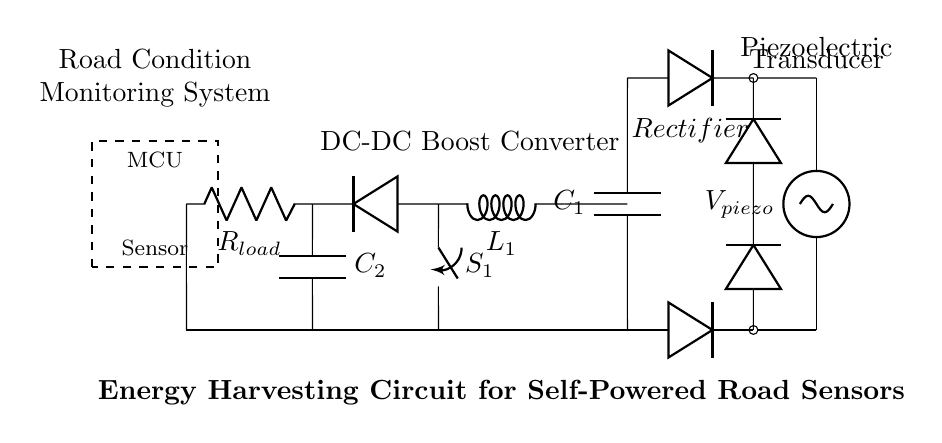What is the main power source in this circuit? The circuit uses a piezoelectric transducer as its main power source, indicated by the labeled voltage source.
Answer: Piezoelectric transducer What does the label "Bridge Rectifier" indicate? The "Bridge Rectifier" is a component that converts alternating current from the piezoelectric source to direct current for the circuit.
Answer: Converts AC to DC What is the role of capacitor C1 in this circuit? Capacitor C1 smoothens the DC voltage output from the rectifier, storing energy and reducing voltage fluctuations.
Answer: Smoothing How does the DC-DC Boost Converter function in this circuit? The DC-DC Boost Converter, consisting of an inductor, capacitors, and diodes, increases the voltage to a higher level suitable for the load and sensor.
Answer: Increases voltage What is the purpose of the load resistor R_load? The load resistor R_load is used to limit the current flowing to the sensor and microcontroller, providing appropriate power for their operation.
Answer: Current limiting What happens when switch S1 is closed? Closing switch S1 allows current to flow from the DC-DC Boost Converter to the load, powering the sensor and microcontroller.
Answer: Powers load What type of system is this circuit designed for? This circuit is specifically designed for a road condition monitoring system to collect data about road conditions using self-powered sensors.
Answer: Road condition monitoring system 